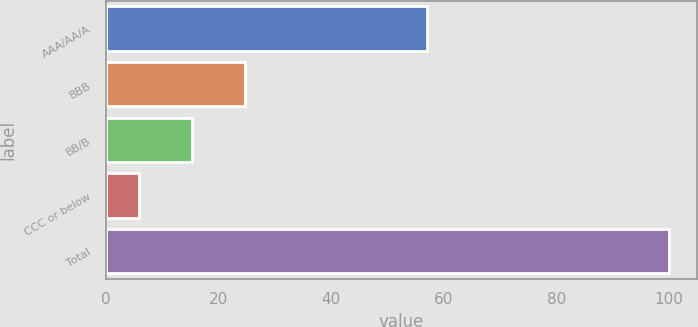Convert chart to OTSL. <chart><loc_0><loc_0><loc_500><loc_500><bar_chart><fcel>AAA/AA/A<fcel>BBB<fcel>BB/B<fcel>CCC or below<fcel>Total<nl><fcel>57<fcel>24.8<fcel>15.4<fcel>6<fcel>100<nl></chart> 